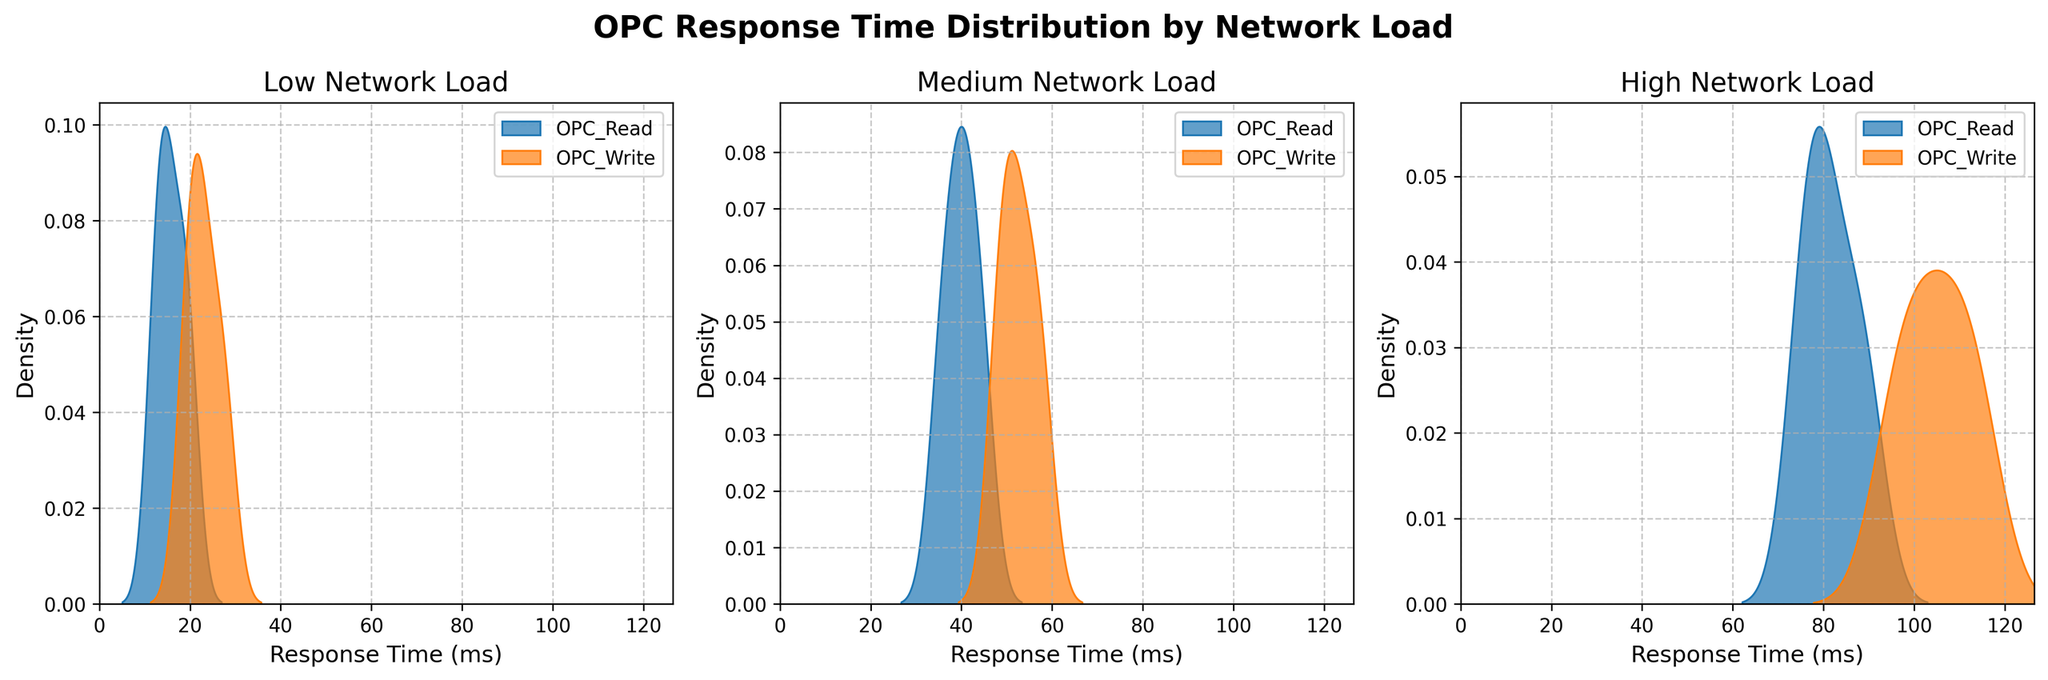What is the title of the figure? The title is usually positioned prominently above the subplots. It should be easy to locate and read.
Answer: OPC Response Time Distribution by Network Load Which network load has the highest maximum response time for OPC_Write operations? Look at the density plot for the 'High' network load. Identify the peak in the density curve for OPC_Write operations and compare it to the peaks under 'Low' and 'Medium' loads.
Answer: High For the 'Medium' network load, which operation has a higher peak density value, OPC_Read or OPC_Write? Examine the density curves under the 'Medium' network load subplot. Determine which operation's density curve reaches a higher value.
Answer: OPC_Read How do the shapes of the density plots for OPC_Read under 'Low' and 'High' network loads compare? Compare the spread and peak of the density curves for OPC_Read under both 'Low' and 'High' network loads. Consider the width and height of the peaks.
Answer: The 'High' network load density plot is wider and has a higher peak Which network load range shows the most overlap between OPC_Read and OPC_Write in response times? Look at each network load subplot and compare the overlap between the OPC_Read and OPC_Write density plots. The network load with the most visible overlapping area has the most overlap.
Answer: Low What is the approximate range of response times for OPC_Write under 'Low' network load? Identify the starting and ending points of the density curve for OPC_Write under 'Low' network load. The range is between these points.
Answer: 19 to 28 ms Which network load has the smallest difference in peak density values between OPC_Read and OPC_Write? Compare the peak density values of OPC_Read and OPC_Write across all network loads. Determine which load has the smallest difference in these peak values.
Answer: Medium In which network load does OPC_Write show a bimodal distribution? Check each density plot for OPC_Write across different network loads to see if there are two peaks, which indicates a bimodal distribution.
Answer: High What can be inferred about OPC_Read response times as network load increases? Evaluate the shift in the peak and spread of the density curves for OPC_Read from 'Low' to 'High' network loads. Observe if the peak shifts to the right (larger response times) and how the spread changes.
Answer: Response times increase and the distribution widens 